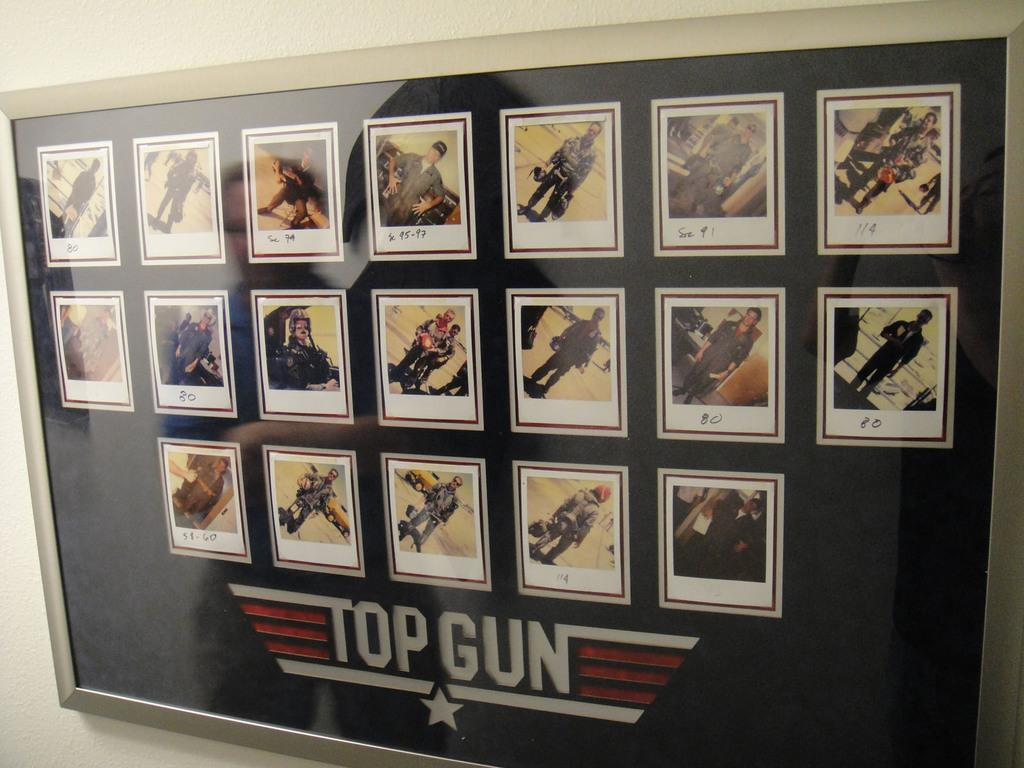<image>
Create a compact narrative representing the image presented. wall display with multiple photos and the top gun words and emblem at bottom 